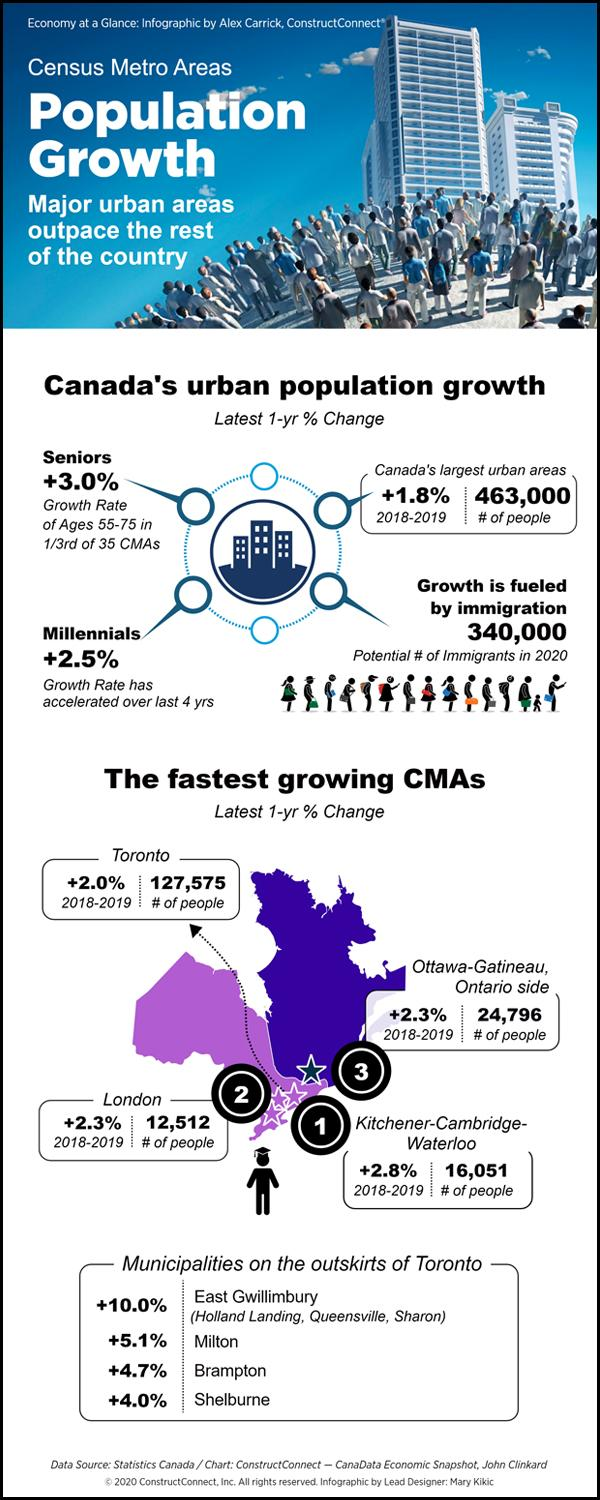Mention a couple of crucial points in this snapshot. This infographic mentions 4 municipalities of Toronto. 